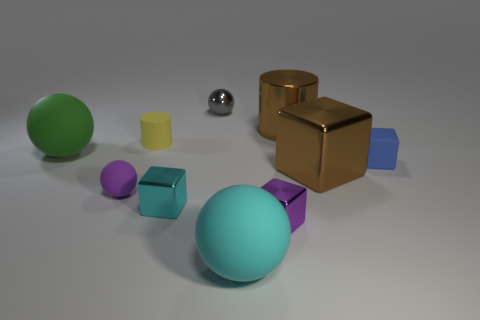Subtract all cyan cubes. How many cubes are left? 3 Subtract all cyan blocks. How many blocks are left? 3 Subtract all cylinders. How many objects are left? 8 Subtract 1 spheres. How many spheres are left? 3 Subtract all yellow spheres. Subtract all gray cubes. How many spheres are left? 4 Subtract all purple blocks. How many brown cylinders are left? 1 Subtract all large cyan matte things. Subtract all tiny purple spheres. How many objects are left? 8 Add 3 green objects. How many green objects are left? 4 Add 7 small gray metallic cylinders. How many small gray metallic cylinders exist? 7 Subtract 0 blue cylinders. How many objects are left? 10 